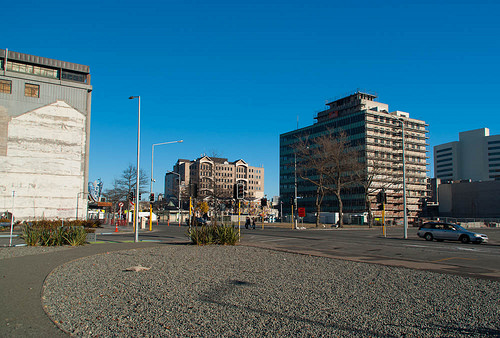<image>
Is there a tree behind the building? No. The tree is not behind the building. From this viewpoint, the tree appears to be positioned elsewhere in the scene. 